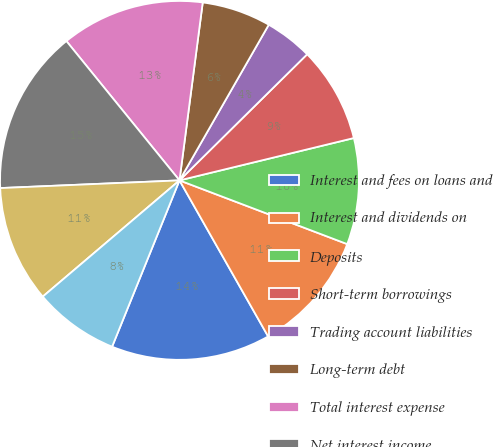Convert chart to OTSL. <chart><loc_0><loc_0><loc_500><loc_500><pie_chart><fcel>Interest and fees on loans and<fcel>Interest and dividends on<fcel>Deposits<fcel>Short-term borrowings<fcel>Trading account liabilities<fcel>Long-term debt<fcel>Total interest expense<fcel>Net interest income<fcel>Servicecharges<fcel>Investment and brokerage<nl><fcel>14.35%<fcel>11.0%<fcel>9.57%<fcel>8.61%<fcel>4.31%<fcel>6.22%<fcel>12.92%<fcel>14.83%<fcel>10.53%<fcel>7.66%<nl></chart> 